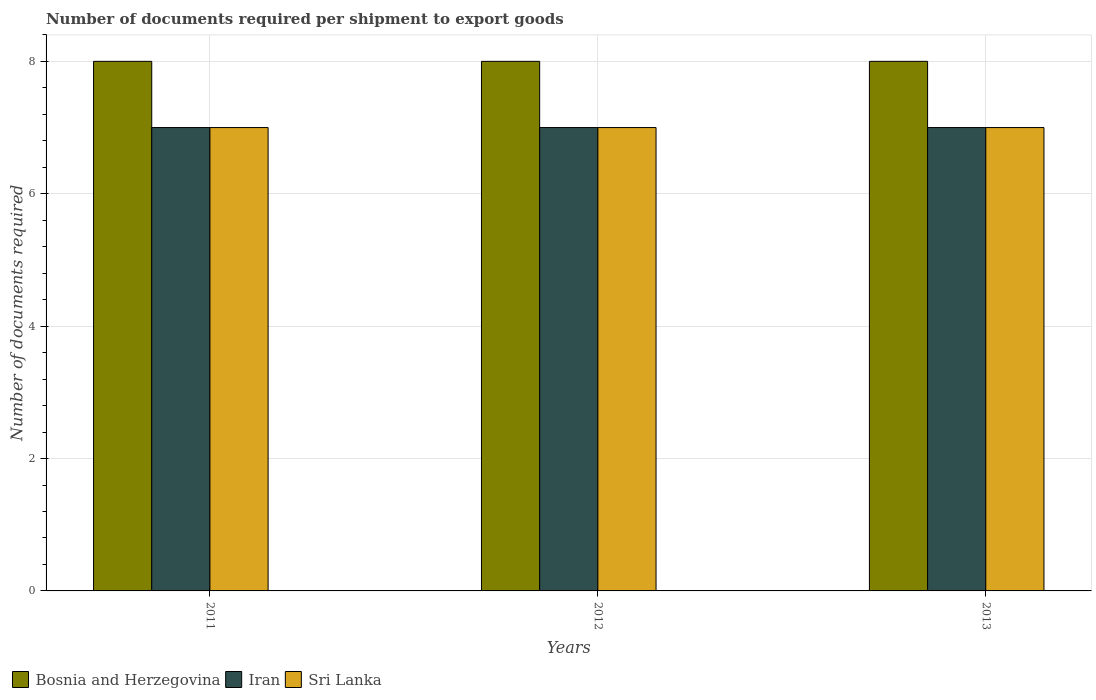How many different coloured bars are there?
Offer a very short reply. 3. Are the number of bars on each tick of the X-axis equal?
Offer a very short reply. Yes. How many bars are there on the 2nd tick from the left?
Give a very brief answer. 3. How many bars are there on the 3rd tick from the right?
Keep it short and to the point. 3. What is the number of documents required per shipment to export goods in Bosnia and Herzegovina in 2012?
Provide a succinct answer. 8. Across all years, what is the maximum number of documents required per shipment to export goods in Bosnia and Herzegovina?
Provide a succinct answer. 8. Across all years, what is the minimum number of documents required per shipment to export goods in Sri Lanka?
Provide a succinct answer. 7. In which year was the number of documents required per shipment to export goods in Sri Lanka maximum?
Ensure brevity in your answer.  2011. In which year was the number of documents required per shipment to export goods in Sri Lanka minimum?
Provide a succinct answer. 2011. What is the total number of documents required per shipment to export goods in Sri Lanka in the graph?
Keep it short and to the point. 21. What is the difference between the number of documents required per shipment to export goods in Iran in 2012 and the number of documents required per shipment to export goods in Bosnia and Herzegovina in 2013?
Offer a terse response. -1. In the year 2012, what is the difference between the number of documents required per shipment to export goods in Sri Lanka and number of documents required per shipment to export goods in Bosnia and Herzegovina?
Your answer should be compact. -1. In how many years, is the number of documents required per shipment to export goods in Sri Lanka greater than 4.8?
Give a very brief answer. 3. Is the difference between the number of documents required per shipment to export goods in Sri Lanka in 2012 and 2013 greater than the difference between the number of documents required per shipment to export goods in Bosnia and Herzegovina in 2012 and 2013?
Your answer should be compact. No. What is the difference between the highest and the second highest number of documents required per shipment to export goods in Bosnia and Herzegovina?
Offer a terse response. 0. What is the difference between the highest and the lowest number of documents required per shipment to export goods in Sri Lanka?
Your answer should be very brief. 0. In how many years, is the number of documents required per shipment to export goods in Bosnia and Herzegovina greater than the average number of documents required per shipment to export goods in Bosnia and Herzegovina taken over all years?
Provide a short and direct response. 0. Is the sum of the number of documents required per shipment to export goods in Iran in 2012 and 2013 greater than the maximum number of documents required per shipment to export goods in Bosnia and Herzegovina across all years?
Offer a terse response. Yes. What does the 2nd bar from the left in 2011 represents?
Keep it short and to the point. Iran. What does the 1st bar from the right in 2011 represents?
Offer a terse response. Sri Lanka. Is it the case that in every year, the sum of the number of documents required per shipment to export goods in Iran and number of documents required per shipment to export goods in Sri Lanka is greater than the number of documents required per shipment to export goods in Bosnia and Herzegovina?
Your answer should be very brief. Yes. How many years are there in the graph?
Provide a short and direct response. 3. Does the graph contain any zero values?
Provide a short and direct response. No. Does the graph contain grids?
Make the answer very short. Yes. How many legend labels are there?
Make the answer very short. 3. How are the legend labels stacked?
Your answer should be very brief. Horizontal. What is the title of the graph?
Give a very brief answer. Number of documents required per shipment to export goods. What is the label or title of the Y-axis?
Your answer should be compact. Number of documents required. What is the Number of documents required of Iran in 2011?
Offer a terse response. 7. What is the Number of documents required in Bosnia and Herzegovina in 2012?
Make the answer very short. 8. What is the Number of documents required of Sri Lanka in 2012?
Ensure brevity in your answer.  7. What is the Number of documents required of Bosnia and Herzegovina in 2013?
Ensure brevity in your answer.  8. Across all years, what is the maximum Number of documents required of Bosnia and Herzegovina?
Your response must be concise. 8. Across all years, what is the maximum Number of documents required in Iran?
Offer a very short reply. 7. Across all years, what is the minimum Number of documents required in Bosnia and Herzegovina?
Provide a short and direct response. 8. What is the total Number of documents required of Iran in the graph?
Give a very brief answer. 21. What is the difference between the Number of documents required in Iran in 2011 and that in 2012?
Your answer should be compact. 0. What is the difference between the Number of documents required in Bosnia and Herzegovina in 2011 and that in 2013?
Your answer should be very brief. 0. What is the difference between the Number of documents required of Iran in 2011 and that in 2013?
Offer a very short reply. 0. What is the difference between the Number of documents required in Sri Lanka in 2012 and that in 2013?
Offer a very short reply. 0. What is the difference between the Number of documents required in Bosnia and Herzegovina in 2011 and the Number of documents required in Sri Lanka in 2013?
Provide a short and direct response. 1. What is the difference between the Number of documents required in Iran in 2011 and the Number of documents required in Sri Lanka in 2013?
Provide a succinct answer. 0. What is the difference between the Number of documents required of Bosnia and Herzegovina in 2012 and the Number of documents required of Iran in 2013?
Offer a terse response. 1. What is the average Number of documents required of Bosnia and Herzegovina per year?
Keep it short and to the point. 8. What is the average Number of documents required of Iran per year?
Your answer should be compact. 7. What is the average Number of documents required of Sri Lanka per year?
Offer a very short reply. 7. In the year 2011, what is the difference between the Number of documents required in Bosnia and Herzegovina and Number of documents required in Iran?
Keep it short and to the point. 1. In the year 2011, what is the difference between the Number of documents required in Bosnia and Herzegovina and Number of documents required in Sri Lanka?
Provide a short and direct response. 1. In the year 2011, what is the difference between the Number of documents required in Iran and Number of documents required in Sri Lanka?
Your response must be concise. 0. In the year 2012, what is the difference between the Number of documents required of Bosnia and Herzegovina and Number of documents required of Iran?
Offer a very short reply. 1. In the year 2013, what is the difference between the Number of documents required of Bosnia and Herzegovina and Number of documents required of Iran?
Make the answer very short. 1. What is the ratio of the Number of documents required of Bosnia and Herzegovina in 2011 to that in 2012?
Your answer should be very brief. 1. What is the ratio of the Number of documents required in Iran in 2011 to that in 2012?
Your response must be concise. 1. What is the ratio of the Number of documents required of Sri Lanka in 2011 to that in 2012?
Provide a short and direct response. 1. What is the ratio of the Number of documents required of Bosnia and Herzegovina in 2011 to that in 2013?
Make the answer very short. 1. What is the ratio of the Number of documents required in Sri Lanka in 2011 to that in 2013?
Keep it short and to the point. 1. What is the ratio of the Number of documents required in Iran in 2012 to that in 2013?
Your answer should be compact. 1. What is the difference between the highest and the second highest Number of documents required in Bosnia and Herzegovina?
Offer a very short reply. 0. What is the difference between the highest and the second highest Number of documents required in Iran?
Your answer should be compact. 0. What is the difference between the highest and the lowest Number of documents required in Iran?
Make the answer very short. 0. What is the difference between the highest and the lowest Number of documents required in Sri Lanka?
Keep it short and to the point. 0. 